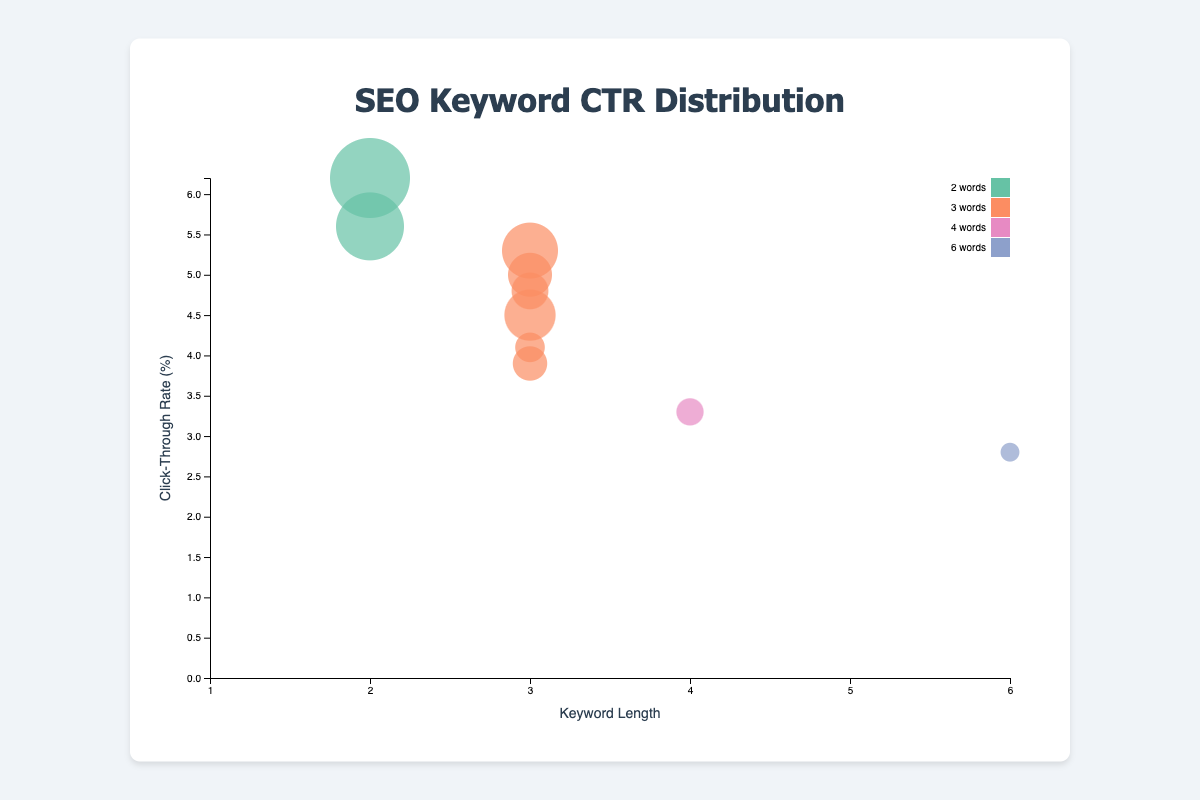How many keywords have a length of 3 words? By observing the visual appearance of the bubble chart, identify the number of bubbles that belong to the color associated with keywords of length 3 words.
Answer: 6 What is the title of the chart? Look at the text displayed at the top of the chart within the chart container.
Answer: SEO Keyword CTR Distribution Which keyword has the highest click-through rate (CTR)? Analyze the vertical position of the bubbles; the highest bubble on the y-axis represents the highest CTR.
Answer: JavaScript tutorials What is the average search volume for keywords with a length of 2 and 3 words? Sum the search volumes for keywords with lengths of 2 (2500 + 3000) and 3 words (1100 + 1800 + 900 + 1500 + 1200 + 2000). Divide the total by the count of these keywords (2 for 2 words and 6 for 3 words).
Answer: 1712.5 Does keyword length directly correlate with higher CTRs? Compare the heights of bubbles along the y-axis for different keyword lengths. Evaluate whether shorter keywords consistently appear higher.
Answer: No Which keyword with a length of 3 words has the lowest CTR? Concentrate on the bubbles colored for 3-word keywords and identify the one closest to the y-axis bottom.
Answer: responsive design principles How does the size of the bubbles change with search volume? Observe the variation in the sizes of the circles corresponding to their search volumes. Larger search volumes have larger bubbles.
Answer: Larger search volume results in larger bubbles For keywords with the same CTR, which has a higher search volume: "improve website speed" or "website accessibility tips"? Locate the bubbles for these two keywords and compare their sizes directly.
Answer: improve website speed What is the keyword and length of the keyword with the smallest bubble? Identify the bubble with the smallest size, then check the associated keyword and its length.
Answer: how to optimize images for web, 6 words Which keyword length has the most variety in CTR values? Compare the spread of the bubbles along the y-axis within each group of keywords of specific lengths. The group with the largest vertical spread has the most variety.
Answer: 3 words 